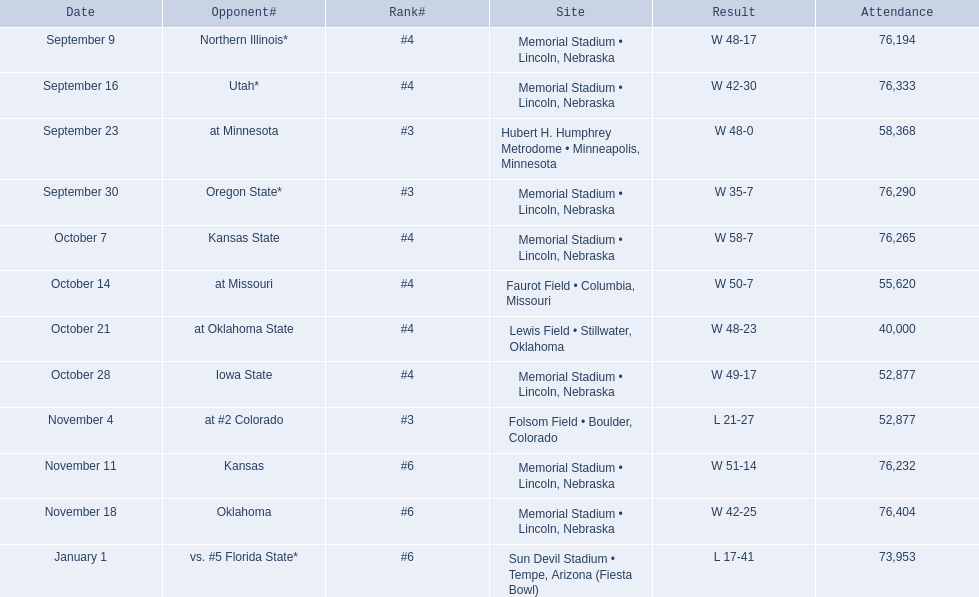When did nebraska play oregon state? September 30. What was the attendance at the september 30 game? 76,290. 